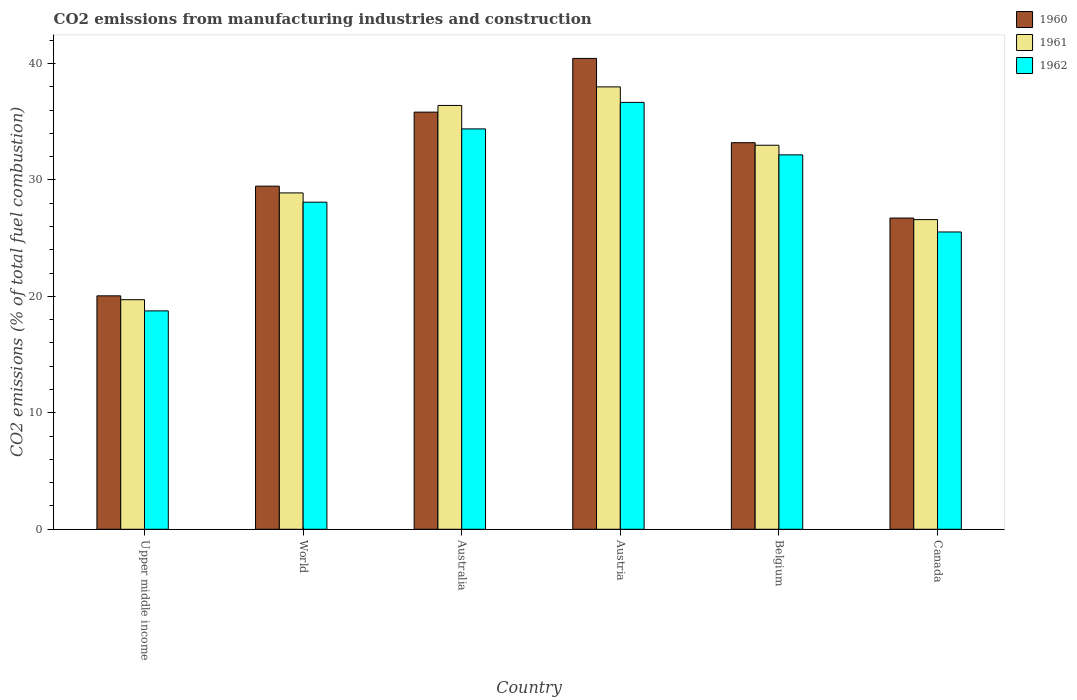How many bars are there on the 2nd tick from the left?
Your response must be concise. 3. How many bars are there on the 4th tick from the right?
Offer a terse response. 3. What is the label of the 1st group of bars from the left?
Your response must be concise. Upper middle income. What is the amount of CO2 emitted in 1961 in Canada?
Offer a very short reply. 26.59. Across all countries, what is the maximum amount of CO2 emitted in 1962?
Your response must be concise. 36.66. Across all countries, what is the minimum amount of CO2 emitted in 1962?
Provide a short and direct response. 18.76. In which country was the amount of CO2 emitted in 1960 maximum?
Make the answer very short. Austria. In which country was the amount of CO2 emitted in 1960 minimum?
Make the answer very short. Upper middle income. What is the total amount of CO2 emitted in 1961 in the graph?
Offer a very short reply. 182.58. What is the difference between the amount of CO2 emitted in 1960 in Upper middle income and that in World?
Your answer should be compact. -9.42. What is the difference between the amount of CO2 emitted in 1962 in Australia and the amount of CO2 emitted in 1961 in World?
Offer a terse response. 5.5. What is the average amount of CO2 emitted in 1960 per country?
Provide a short and direct response. 30.95. What is the difference between the amount of CO2 emitted of/in 1960 and amount of CO2 emitted of/in 1962 in Austria?
Ensure brevity in your answer.  3.78. What is the ratio of the amount of CO2 emitted in 1961 in Belgium to that in Canada?
Your answer should be compact. 1.24. Is the difference between the amount of CO2 emitted in 1960 in Belgium and Canada greater than the difference between the amount of CO2 emitted in 1962 in Belgium and Canada?
Offer a very short reply. No. What is the difference between the highest and the second highest amount of CO2 emitted in 1961?
Make the answer very short. -3.42. What is the difference between the highest and the lowest amount of CO2 emitted in 1960?
Give a very brief answer. 20.39. What does the 3rd bar from the left in World represents?
Your response must be concise. 1962. Are all the bars in the graph horizontal?
Give a very brief answer. No. How many countries are there in the graph?
Make the answer very short. 6. What is the difference between two consecutive major ticks on the Y-axis?
Offer a very short reply. 10. Does the graph contain any zero values?
Provide a short and direct response. No. Does the graph contain grids?
Make the answer very short. No. Where does the legend appear in the graph?
Offer a terse response. Top right. What is the title of the graph?
Give a very brief answer. CO2 emissions from manufacturing industries and construction. Does "2010" appear as one of the legend labels in the graph?
Ensure brevity in your answer.  No. What is the label or title of the Y-axis?
Give a very brief answer. CO2 emissions (% of total fuel combustion). What is the CO2 emissions (% of total fuel combustion) of 1960 in Upper middle income?
Ensure brevity in your answer.  20.05. What is the CO2 emissions (% of total fuel combustion) in 1961 in Upper middle income?
Your answer should be compact. 19.72. What is the CO2 emissions (% of total fuel combustion) of 1962 in Upper middle income?
Keep it short and to the point. 18.76. What is the CO2 emissions (% of total fuel combustion) of 1960 in World?
Make the answer very short. 29.47. What is the CO2 emissions (% of total fuel combustion) in 1961 in World?
Offer a terse response. 28.89. What is the CO2 emissions (% of total fuel combustion) in 1962 in World?
Keep it short and to the point. 28.09. What is the CO2 emissions (% of total fuel combustion) in 1960 in Australia?
Make the answer very short. 35.83. What is the CO2 emissions (% of total fuel combustion) of 1961 in Australia?
Keep it short and to the point. 36.4. What is the CO2 emissions (% of total fuel combustion) of 1962 in Australia?
Make the answer very short. 34.39. What is the CO2 emissions (% of total fuel combustion) in 1960 in Austria?
Your answer should be compact. 40.44. What is the CO2 emissions (% of total fuel combustion) in 1961 in Austria?
Ensure brevity in your answer.  37.99. What is the CO2 emissions (% of total fuel combustion) of 1962 in Austria?
Make the answer very short. 36.66. What is the CO2 emissions (% of total fuel combustion) in 1960 in Belgium?
Keep it short and to the point. 33.2. What is the CO2 emissions (% of total fuel combustion) of 1961 in Belgium?
Provide a succinct answer. 32.98. What is the CO2 emissions (% of total fuel combustion) of 1962 in Belgium?
Your answer should be compact. 32.16. What is the CO2 emissions (% of total fuel combustion) of 1960 in Canada?
Ensure brevity in your answer.  26.73. What is the CO2 emissions (% of total fuel combustion) in 1961 in Canada?
Your answer should be compact. 26.59. What is the CO2 emissions (% of total fuel combustion) in 1962 in Canada?
Offer a terse response. 25.53. Across all countries, what is the maximum CO2 emissions (% of total fuel combustion) in 1960?
Ensure brevity in your answer.  40.44. Across all countries, what is the maximum CO2 emissions (% of total fuel combustion) in 1961?
Give a very brief answer. 37.99. Across all countries, what is the maximum CO2 emissions (% of total fuel combustion) of 1962?
Offer a very short reply. 36.66. Across all countries, what is the minimum CO2 emissions (% of total fuel combustion) of 1960?
Your answer should be very brief. 20.05. Across all countries, what is the minimum CO2 emissions (% of total fuel combustion) of 1961?
Ensure brevity in your answer.  19.72. Across all countries, what is the minimum CO2 emissions (% of total fuel combustion) in 1962?
Ensure brevity in your answer.  18.76. What is the total CO2 emissions (% of total fuel combustion) in 1960 in the graph?
Offer a very short reply. 185.71. What is the total CO2 emissions (% of total fuel combustion) of 1961 in the graph?
Keep it short and to the point. 182.58. What is the total CO2 emissions (% of total fuel combustion) in 1962 in the graph?
Your response must be concise. 175.59. What is the difference between the CO2 emissions (% of total fuel combustion) in 1960 in Upper middle income and that in World?
Offer a terse response. -9.42. What is the difference between the CO2 emissions (% of total fuel combustion) in 1961 in Upper middle income and that in World?
Offer a very short reply. -9.17. What is the difference between the CO2 emissions (% of total fuel combustion) of 1962 in Upper middle income and that in World?
Provide a short and direct response. -9.34. What is the difference between the CO2 emissions (% of total fuel combustion) of 1960 in Upper middle income and that in Australia?
Offer a very short reply. -15.78. What is the difference between the CO2 emissions (% of total fuel combustion) in 1961 in Upper middle income and that in Australia?
Provide a short and direct response. -16.68. What is the difference between the CO2 emissions (% of total fuel combustion) of 1962 in Upper middle income and that in Australia?
Offer a very short reply. -15.63. What is the difference between the CO2 emissions (% of total fuel combustion) in 1960 in Upper middle income and that in Austria?
Give a very brief answer. -20.39. What is the difference between the CO2 emissions (% of total fuel combustion) in 1961 in Upper middle income and that in Austria?
Offer a very short reply. -18.28. What is the difference between the CO2 emissions (% of total fuel combustion) of 1962 in Upper middle income and that in Austria?
Make the answer very short. -17.9. What is the difference between the CO2 emissions (% of total fuel combustion) of 1960 in Upper middle income and that in Belgium?
Provide a succinct answer. -13.15. What is the difference between the CO2 emissions (% of total fuel combustion) of 1961 in Upper middle income and that in Belgium?
Your answer should be compact. -13.27. What is the difference between the CO2 emissions (% of total fuel combustion) of 1962 in Upper middle income and that in Belgium?
Make the answer very short. -13.4. What is the difference between the CO2 emissions (% of total fuel combustion) of 1960 in Upper middle income and that in Canada?
Keep it short and to the point. -6.68. What is the difference between the CO2 emissions (% of total fuel combustion) of 1961 in Upper middle income and that in Canada?
Keep it short and to the point. -6.88. What is the difference between the CO2 emissions (% of total fuel combustion) of 1962 in Upper middle income and that in Canada?
Give a very brief answer. -6.78. What is the difference between the CO2 emissions (% of total fuel combustion) of 1960 in World and that in Australia?
Give a very brief answer. -6.36. What is the difference between the CO2 emissions (% of total fuel combustion) in 1961 in World and that in Australia?
Offer a very short reply. -7.51. What is the difference between the CO2 emissions (% of total fuel combustion) in 1962 in World and that in Australia?
Provide a short and direct response. -6.29. What is the difference between the CO2 emissions (% of total fuel combustion) in 1960 in World and that in Austria?
Ensure brevity in your answer.  -10.97. What is the difference between the CO2 emissions (% of total fuel combustion) of 1961 in World and that in Austria?
Offer a terse response. -9.11. What is the difference between the CO2 emissions (% of total fuel combustion) of 1962 in World and that in Austria?
Your answer should be very brief. -8.57. What is the difference between the CO2 emissions (% of total fuel combustion) in 1960 in World and that in Belgium?
Give a very brief answer. -3.73. What is the difference between the CO2 emissions (% of total fuel combustion) of 1961 in World and that in Belgium?
Give a very brief answer. -4.09. What is the difference between the CO2 emissions (% of total fuel combustion) of 1962 in World and that in Belgium?
Offer a very short reply. -4.06. What is the difference between the CO2 emissions (% of total fuel combustion) of 1960 in World and that in Canada?
Your answer should be very brief. 2.74. What is the difference between the CO2 emissions (% of total fuel combustion) of 1961 in World and that in Canada?
Keep it short and to the point. 2.29. What is the difference between the CO2 emissions (% of total fuel combustion) of 1962 in World and that in Canada?
Your answer should be very brief. 2.56. What is the difference between the CO2 emissions (% of total fuel combustion) of 1960 in Australia and that in Austria?
Keep it short and to the point. -4.61. What is the difference between the CO2 emissions (% of total fuel combustion) in 1961 in Australia and that in Austria?
Provide a short and direct response. -1.6. What is the difference between the CO2 emissions (% of total fuel combustion) of 1962 in Australia and that in Austria?
Give a very brief answer. -2.28. What is the difference between the CO2 emissions (% of total fuel combustion) in 1960 in Australia and that in Belgium?
Offer a very short reply. 2.63. What is the difference between the CO2 emissions (% of total fuel combustion) of 1961 in Australia and that in Belgium?
Keep it short and to the point. 3.42. What is the difference between the CO2 emissions (% of total fuel combustion) in 1962 in Australia and that in Belgium?
Your answer should be compact. 2.23. What is the difference between the CO2 emissions (% of total fuel combustion) of 1960 in Australia and that in Canada?
Provide a succinct answer. 9.1. What is the difference between the CO2 emissions (% of total fuel combustion) in 1961 in Australia and that in Canada?
Make the answer very short. 9.81. What is the difference between the CO2 emissions (% of total fuel combustion) of 1962 in Australia and that in Canada?
Your answer should be compact. 8.85. What is the difference between the CO2 emissions (% of total fuel combustion) in 1960 in Austria and that in Belgium?
Provide a short and direct response. 7.24. What is the difference between the CO2 emissions (% of total fuel combustion) of 1961 in Austria and that in Belgium?
Your answer should be very brief. 5.01. What is the difference between the CO2 emissions (% of total fuel combustion) of 1962 in Austria and that in Belgium?
Provide a short and direct response. 4.51. What is the difference between the CO2 emissions (% of total fuel combustion) in 1960 in Austria and that in Canada?
Provide a succinct answer. 13.71. What is the difference between the CO2 emissions (% of total fuel combustion) in 1961 in Austria and that in Canada?
Your response must be concise. 11.4. What is the difference between the CO2 emissions (% of total fuel combustion) in 1962 in Austria and that in Canada?
Your response must be concise. 11.13. What is the difference between the CO2 emissions (% of total fuel combustion) in 1960 in Belgium and that in Canada?
Ensure brevity in your answer.  6.47. What is the difference between the CO2 emissions (% of total fuel combustion) of 1961 in Belgium and that in Canada?
Ensure brevity in your answer.  6.39. What is the difference between the CO2 emissions (% of total fuel combustion) in 1962 in Belgium and that in Canada?
Provide a short and direct response. 6.62. What is the difference between the CO2 emissions (% of total fuel combustion) in 1960 in Upper middle income and the CO2 emissions (% of total fuel combustion) in 1961 in World?
Provide a succinct answer. -8.84. What is the difference between the CO2 emissions (% of total fuel combustion) in 1960 in Upper middle income and the CO2 emissions (% of total fuel combustion) in 1962 in World?
Ensure brevity in your answer.  -8.04. What is the difference between the CO2 emissions (% of total fuel combustion) of 1961 in Upper middle income and the CO2 emissions (% of total fuel combustion) of 1962 in World?
Give a very brief answer. -8.38. What is the difference between the CO2 emissions (% of total fuel combustion) of 1960 in Upper middle income and the CO2 emissions (% of total fuel combustion) of 1961 in Australia?
Provide a short and direct response. -16.35. What is the difference between the CO2 emissions (% of total fuel combustion) in 1960 in Upper middle income and the CO2 emissions (% of total fuel combustion) in 1962 in Australia?
Your answer should be compact. -14.34. What is the difference between the CO2 emissions (% of total fuel combustion) of 1961 in Upper middle income and the CO2 emissions (% of total fuel combustion) of 1962 in Australia?
Make the answer very short. -14.67. What is the difference between the CO2 emissions (% of total fuel combustion) in 1960 in Upper middle income and the CO2 emissions (% of total fuel combustion) in 1961 in Austria?
Make the answer very short. -17.95. What is the difference between the CO2 emissions (% of total fuel combustion) in 1960 in Upper middle income and the CO2 emissions (% of total fuel combustion) in 1962 in Austria?
Give a very brief answer. -16.61. What is the difference between the CO2 emissions (% of total fuel combustion) in 1961 in Upper middle income and the CO2 emissions (% of total fuel combustion) in 1962 in Austria?
Keep it short and to the point. -16.95. What is the difference between the CO2 emissions (% of total fuel combustion) in 1960 in Upper middle income and the CO2 emissions (% of total fuel combustion) in 1961 in Belgium?
Ensure brevity in your answer.  -12.93. What is the difference between the CO2 emissions (% of total fuel combustion) of 1960 in Upper middle income and the CO2 emissions (% of total fuel combustion) of 1962 in Belgium?
Make the answer very short. -12.11. What is the difference between the CO2 emissions (% of total fuel combustion) of 1961 in Upper middle income and the CO2 emissions (% of total fuel combustion) of 1962 in Belgium?
Your response must be concise. -12.44. What is the difference between the CO2 emissions (% of total fuel combustion) in 1960 in Upper middle income and the CO2 emissions (% of total fuel combustion) in 1961 in Canada?
Offer a terse response. -6.55. What is the difference between the CO2 emissions (% of total fuel combustion) in 1960 in Upper middle income and the CO2 emissions (% of total fuel combustion) in 1962 in Canada?
Provide a succinct answer. -5.48. What is the difference between the CO2 emissions (% of total fuel combustion) in 1961 in Upper middle income and the CO2 emissions (% of total fuel combustion) in 1962 in Canada?
Make the answer very short. -5.82. What is the difference between the CO2 emissions (% of total fuel combustion) in 1960 in World and the CO2 emissions (% of total fuel combustion) in 1961 in Australia?
Offer a terse response. -6.93. What is the difference between the CO2 emissions (% of total fuel combustion) of 1960 in World and the CO2 emissions (% of total fuel combustion) of 1962 in Australia?
Offer a very short reply. -4.92. What is the difference between the CO2 emissions (% of total fuel combustion) of 1961 in World and the CO2 emissions (% of total fuel combustion) of 1962 in Australia?
Provide a succinct answer. -5.5. What is the difference between the CO2 emissions (% of total fuel combustion) in 1960 in World and the CO2 emissions (% of total fuel combustion) in 1961 in Austria?
Your response must be concise. -8.53. What is the difference between the CO2 emissions (% of total fuel combustion) in 1960 in World and the CO2 emissions (% of total fuel combustion) in 1962 in Austria?
Offer a very short reply. -7.19. What is the difference between the CO2 emissions (% of total fuel combustion) of 1961 in World and the CO2 emissions (% of total fuel combustion) of 1962 in Austria?
Your response must be concise. -7.77. What is the difference between the CO2 emissions (% of total fuel combustion) of 1960 in World and the CO2 emissions (% of total fuel combustion) of 1961 in Belgium?
Offer a terse response. -3.51. What is the difference between the CO2 emissions (% of total fuel combustion) in 1960 in World and the CO2 emissions (% of total fuel combustion) in 1962 in Belgium?
Your answer should be compact. -2.69. What is the difference between the CO2 emissions (% of total fuel combustion) in 1961 in World and the CO2 emissions (% of total fuel combustion) in 1962 in Belgium?
Ensure brevity in your answer.  -3.27. What is the difference between the CO2 emissions (% of total fuel combustion) of 1960 in World and the CO2 emissions (% of total fuel combustion) of 1961 in Canada?
Provide a succinct answer. 2.87. What is the difference between the CO2 emissions (% of total fuel combustion) in 1960 in World and the CO2 emissions (% of total fuel combustion) in 1962 in Canada?
Make the answer very short. 3.94. What is the difference between the CO2 emissions (% of total fuel combustion) of 1961 in World and the CO2 emissions (% of total fuel combustion) of 1962 in Canada?
Keep it short and to the point. 3.35. What is the difference between the CO2 emissions (% of total fuel combustion) in 1960 in Australia and the CO2 emissions (% of total fuel combustion) in 1961 in Austria?
Provide a succinct answer. -2.17. What is the difference between the CO2 emissions (% of total fuel combustion) in 1960 in Australia and the CO2 emissions (% of total fuel combustion) in 1962 in Austria?
Give a very brief answer. -0.84. What is the difference between the CO2 emissions (% of total fuel combustion) in 1961 in Australia and the CO2 emissions (% of total fuel combustion) in 1962 in Austria?
Provide a succinct answer. -0.26. What is the difference between the CO2 emissions (% of total fuel combustion) in 1960 in Australia and the CO2 emissions (% of total fuel combustion) in 1961 in Belgium?
Your response must be concise. 2.84. What is the difference between the CO2 emissions (% of total fuel combustion) of 1960 in Australia and the CO2 emissions (% of total fuel combustion) of 1962 in Belgium?
Make the answer very short. 3.67. What is the difference between the CO2 emissions (% of total fuel combustion) in 1961 in Australia and the CO2 emissions (% of total fuel combustion) in 1962 in Belgium?
Your answer should be very brief. 4.24. What is the difference between the CO2 emissions (% of total fuel combustion) in 1960 in Australia and the CO2 emissions (% of total fuel combustion) in 1961 in Canada?
Give a very brief answer. 9.23. What is the difference between the CO2 emissions (% of total fuel combustion) in 1960 in Australia and the CO2 emissions (% of total fuel combustion) in 1962 in Canada?
Offer a terse response. 10.29. What is the difference between the CO2 emissions (% of total fuel combustion) of 1961 in Australia and the CO2 emissions (% of total fuel combustion) of 1962 in Canada?
Your answer should be very brief. 10.87. What is the difference between the CO2 emissions (% of total fuel combustion) of 1960 in Austria and the CO2 emissions (% of total fuel combustion) of 1961 in Belgium?
Your answer should be compact. 7.46. What is the difference between the CO2 emissions (% of total fuel combustion) of 1960 in Austria and the CO2 emissions (% of total fuel combustion) of 1962 in Belgium?
Your answer should be very brief. 8.28. What is the difference between the CO2 emissions (% of total fuel combustion) in 1961 in Austria and the CO2 emissions (% of total fuel combustion) in 1962 in Belgium?
Your answer should be very brief. 5.84. What is the difference between the CO2 emissions (% of total fuel combustion) of 1960 in Austria and the CO2 emissions (% of total fuel combustion) of 1961 in Canada?
Keep it short and to the point. 13.84. What is the difference between the CO2 emissions (% of total fuel combustion) of 1960 in Austria and the CO2 emissions (% of total fuel combustion) of 1962 in Canada?
Your answer should be compact. 14.91. What is the difference between the CO2 emissions (% of total fuel combustion) of 1961 in Austria and the CO2 emissions (% of total fuel combustion) of 1962 in Canada?
Make the answer very short. 12.46. What is the difference between the CO2 emissions (% of total fuel combustion) of 1960 in Belgium and the CO2 emissions (% of total fuel combustion) of 1961 in Canada?
Offer a terse response. 6.61. What is the difference between the CO2 emissions (% of total fuel combustion) of 1960 in Belgium and the CO2 emissions (% of total fuel combustion) of 1962 in Canada?
Your response must be concise. 7.67. What is the difference between the CO2 emissions (% of total fuel combustion) in 1961 in Belgium and the CO2 emissions (% of total fuel combustion) in 1962 in Canada?
Offer a very short reply. 7.45. What is the average CO2 emissions (% of total fuel combustion) in 1960 per country?
Offer a very short reply. 30.95. What is the average CO2 emissions (% of total fuel combustion) in 1961 per country?
Provide a short and direct response. 30.43. What is the average CO2 emissions (% of total fuel combustion) of 1962 per country?
Keep it short and to the point. 29.26. What is the difference between the CO2 emissions (% of total fuel combustion) in 1960 and CO2 emissions (% of total fuel combustion) in 1961 in Upper middle income?
Your answer should be compact. 0.33. What is the difference between the CO2 emissions (% of total fuel combustion) in 1960 and CO2 emissions (% of total fuel combustion) in 1962 in Upper middle income?
Keep it short and to the point. 1.29. What is the difference between the CO2 emissions (% of total fuel combustion) of 1961 and CO2 emissions (% of total fuel combustion) of 1962 in Upper middle income?
Ensure brevity in your answer.  0.96. What is the difference between the CO2 emissions (% of total fuel combustion) in 1960 and CO2 emissions (% of total fuel combustion) in 1961 in World?
Keep it short and to the point. 0.58. What is the difference between the CO2 emissions (% of total fuel combustion) in 1960 and CO2 emissions (% of total fuel combustion) in 1962 in World?
Your response must be concise. 1.38. What is the difference between the CO2 emissions (% of total fuel combustion) of 1961 and CO2 emissions (% of total fuel combustion) of 1962 in World?
Offer a very short reply. 0.79. What is the difference between the CO2 emissions (% of total fuel combustion) of 1960 and CO2 emissions (% of total fuel combustion) of 1961 in Australia?
Give a very brief answer. -0.57. What is the difference between the CO2 emissions (% of total fuel combustion) in 1960 and CO2 emissions (% of total fuel combustion) in 1962 in Australia?
Offer a very short reply. 1.44. What is the difference between the CO2 emissions (% of total fuel combustion) of 1961 and CO2 emissions (% of total fuel combustion) of 1962 in Australia?
Make the answer very short. 2.01. What is the difference between the CO2 emissions (% of total fuel combustion) in 1960 and CO2 emissions (% of total fuel combustion) in 1961 in Austria?
Provide a short and direct response. 2.44. What is the difference between the CO2 emissions (% of total fuel combustion) in 1960 and CO2 emissions (% of total fuel combustion) in 1962 in Austria?
Keep it short and to the point. 3.78. What is the difference between the CO2 emissions (% of total fuel combustion) of 1961 and CO2 emissions (% of total fuel combustion) of 1962 in Austria?
Keep it short and to the point. 1.33. What is the difference between the CO2 emissions (% of total fuel combustion) in 1960 and CO2 emissions (% of total fuel combustion) in 1961 in Belgium?
Your answer should be compact. 0.22. What is the difference between the CO2 emissions (% of total fuel combustion) of 1960 and CO2 emissions (% of total fuel combustion) of 1962 in Belgium?
Your response must be concise. 1.04. What is the difference between the CO2 emissions (% of total fuel combustion) of 1961 and CO2 emissions (% of total fuel combustion) of 1962 in Belgium?
Your answer should be compact. 0.83. What is the difference between the CO2 emissions (% of total fuel combustion) in 1960 and CO2 emissions (% of total fuel combustion) in 1961 in Canada?
Keep it short and to the point. 0.14. What is the difference between the CO2 emissions (% of total fuel combustion) in 1960 and CO2 emissions (% of total fuel combustion) in 1962 in Canada?
Give a very brief answer. 1.2. What is the difference between the CO2 emissions (% of total fuel combustion) of 1961 and CO2 emissions (% of total fuel combustion) of 1962 in Canada?
Make the answer very short. 1.06. What is the ratio of the CO2 emissions (% of total fuel combustion) of 1960 in Upper middle income to that in World?
Provide a succinct answer. 0.68. What is the ratio of the CO2 emissions (% of total fuel combustion) of 1961 in Upper middle income to that in World?
Your response must be concise. 0.68. What is the ratio of the CO2 emissions (% of total fuel combustion) of 1962 in Upper middle income to that in World?
Your answer should be very brief. 0.67. What is the ratio of the CO2 emissions (% of total fuel combustion) of 1960 in Upper middle income to that in Australia?
Provide a short and direct response. 0.56. What is the ratio of the CO2 emissions (% of total fuel combustion) of 1961 in Upper middle income to that in Australia?
Ensure brevity in your answer.  0.54. What is the ratio of the CO2 emissions (% of total fuel combustion) in 1962 in Upper middle income to that in Australia?
Offer a very short reply. 0.55. What is the ratio of the CO2 emissions (% of total fuel combustion) of 1960 in Upper middle income to that in Austria?
Give a very brief answer. 0.5. What is the ratio of the CO2 emissions (% of total fuel combustion) in 1961 in Upper middle income to that in Austria?
Your response must be concise. 0.52. What is the ratio of the CO2 emissions (% of total fuel combustion) in 1962 in Upper middle income to that in Austria?
Give a very brief answer. 0.51. What is the ratio of the CO2 emissions (% of total fuel combustion) in 1960 in Upper middle income to that in Belgium?
Ensure brevity in your answer.  0.6. What is the ratio of the CO2 emissions (% of total fuel combustion) in 1961 in Upper middle income to that in Belgium?
Ensure brevity in your answer.  0.6. What is the ratio of the CO2 emissions (% of total fuel combustion) in 1962 in Upper middle income to that in Belgium?
Offer a terse response. 0.58. What is the ratio of the CO2 emissions (% of total fuel combustion) of 1960 in Upper middle income to that in Canada?
Your answer should be very brief. 0.75. What is the ratio of the CO2 emissions (% of total fuel combustion) of 1961 in Upper middle income to that in Canada?
Make the answer very short. 0.74. What is the ratio of the CO2 emissions (% of total fuel combustion) of 1962 in Upper middle income to that in Canada?
Your answer should be very brief. 0.73. What is the ratio of the CO2 emissions (% of total fuel combustion) in 1960 in World to that in Australia?
Keep it short and to the point. 0.82. What is the ratio of the CO2 emissions (% of total fuel combustion) in 1961 in World to that in Australia?
Provide a short and direct response. 0.79. What is the ratio of the CO2 emissions (% of total fuel combustion) in 1962 in World to that in Australia?
Your answer should be very brief. 0.82. What is the ratio of the CO2 emissions (% of total fuel combustion) in 1960 in World to that in Austria?
Your response must be concise. 0.73. What is the ratio of the CO2 emissions (% of total fuel combustion) of 1961 in World to that in Austria?
Your answer should be compact. 0.76. What is the ratio of the CO2 emissions (% of total fuel combustion) of 1962 in World to that in Austria?
Your response must be concise. 0.77. What is the ratio of the CO2 emissions (% of total fuel combustion) in 1960 in World to that in Belgium?
Give a very brief answer. 0.89. What is the ratio of the CO2 emissions (% of total fuel combustion) of 1961 in World to that in Belgium?
Offer a terse response. 0.88. What is the ratio of the CO2 emissions (% of total fuel combustion) of 1962 in World to that in Belgium?
Your answer should be very brief. 0.87. What is the ratio of the CO2 emissions (% of total fuel combustion) of 1960 in World to that in Canada?
Your response must be concise. 1.1. What is the ratio of the CO2 emissions (% of total fuel combustion) in 1961 in World to that in Canada?
Provide a succinct answer. 1.09. What is the ratio of the CO2 emissions (% of total fuel combustion) in 1962 in World to that in Canada?
Your response must be concise. 1.1. What is the ratio of the CO2 emissions (% of total fuel combustion) of 1960 in Australia to that in Austria?
Your response must be concise. 0.89. What is the ratio of the CO2 emissions (% of total fuel combustion) of 1961 in Australia to that in Austria?
Provide a succinct answer. 0.96. What is the ratio of the CO2 emissions (% of total fuel combustion) in 1962 in Australia to that in Austria?
Provide a succinct answer. 0.94. What is the ratio of the CO2 emissions (% of total fuel combustion) of 1960 in Australia to that in Belgium?
Provide a short and direct response. 1.08. What is the ratio of the CO2 emissions (% of total fuel combustion) in 1961 in Australia to that in Belgium?
Make the answer very short. 1.1. What is the ratio of the CO2 emissions (% of total fuel combustion) of 1962 in Australia to that in Belgium?
Your answer should be very brief. 1.07. What is the ratio of the CO2 emissions (% of total fuel combustion) in 1960 in Australia to that in Canada?
Keep it short and to the point. 1.34. What is the ratio of the CO2 emissions (% of total fuel combustion) of 1961 in Australia to that in Canada?
Give a very brief answer. 1.37. What is the ratio of the CO2 emissions (% of total fuel combustion) in 1962 in Australia to that in Canada?
Offer a terse response. 1.35. What is the ratio of the CO2 emissions (% of total fuel combustion) in 1960 in Austria to that in Belgium?
Your response must be concise. 1.22. What is the ratio of the CO2 emissions (% of total fuel combustion) in 1961 in Austria to that in Belgium?
Your answer should be compact. 1.15. What is the ratio of the CO2 emissions (% of total fuel combustion) of 1962 in Austria to that in Belgium?
Make the answer very short. 1.14. What is the ratio of the CO2 emissions (% of total fuel combustion) in 1960 in Austria to that in Canada?
Give a very brief answer. 1.51. What is the ratio of the CO2 emissions (% of total fuel combustion) of 1961 in Austria to that in Canada?
Ensure brevity in your answer.  1.43. What is the ratio of the CO2 emissions (% of total fuel combustion) in 1962 in Austria to that in Canada?
Make the answer very short. 1.44. What is the ratio of the CO2 emissions (% of total fuel combustion) of 1960 in Belgium to that in Canada?
Ensure brevity in your answer.  1.24. What is the ratio of the CO2 emissions (% of total fuel combustion) in 1961 in Belgium to that in Canada?
Offer a very short reply. 1.24. What is the ratio of the CO2 emissions (% of total fuel combustion) of 1962 in Belgium to that in Canada?
Make the answer very short. 1.26. What is the difference between the highest and the second highest CO2 emissions (% of total fuel combustion) in 1960?
Ensure brevity in your answer.  4.61. What is the difference between the highest and the second highest CO2 emissions (% of total fuel combustion) of 1961?
Offer a terse response. 1.6. What is the difference between the highest and the second highest CO2 emissions (% of total fuel combustion) in 1962?
Ensure brevity in your answer.  2.28. What is the difference between the highest and the lowest CO2 emissions (% of total fuel combustion) in 1960?
Your answer should be compact. 20.39. What is the difference between the highest and the lowest CO2 emissions (% of total fuel combustion) in 1961?
Offer a terse response. 18.28. What is the difference between the highest and the lowest CO2 emissions (% of total fuel combustion) of 1962?
Ensure brevity in your answer.  17.9. 